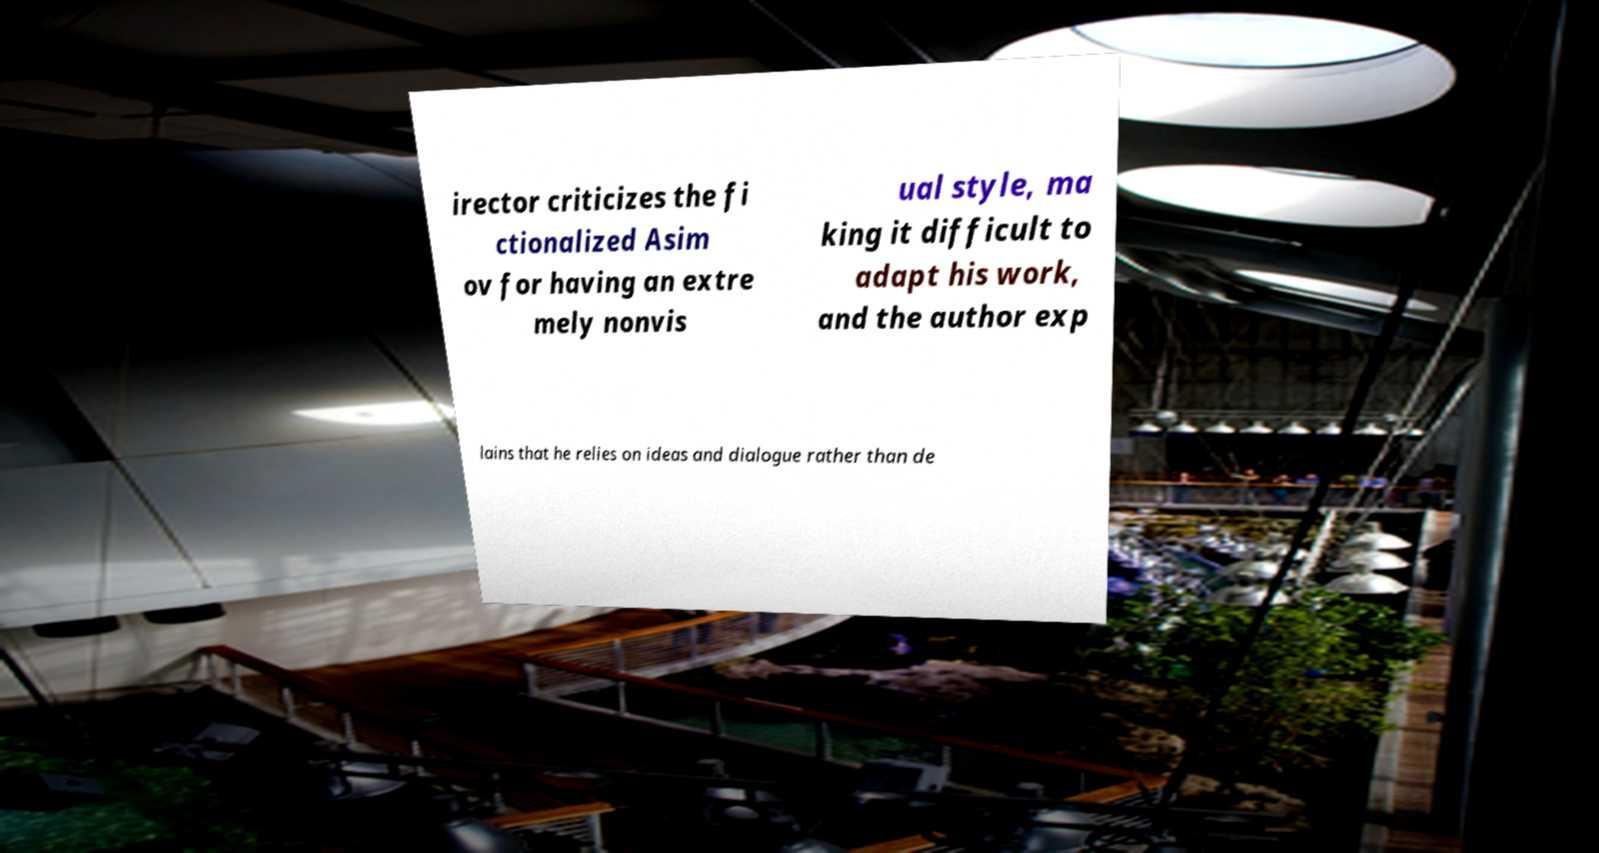Can you accurately transcribe the text from the provided image for me? irector criticizes the fi ctionalized Asim ov for having an extre mely nonvis ual style, ma king it difficult to adapt his work, and the author exp lains that he relies on ideas and dialogue rather than de 